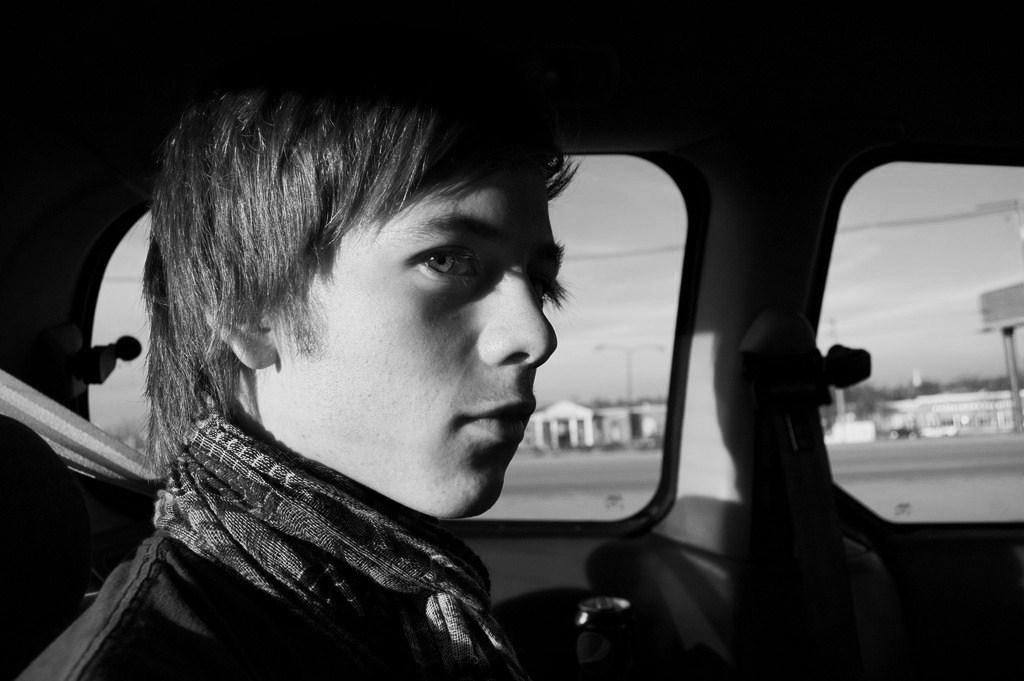Can you describe this image briefly? In this image we can see this person is sitting in the car. 